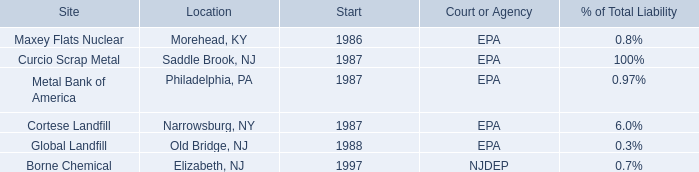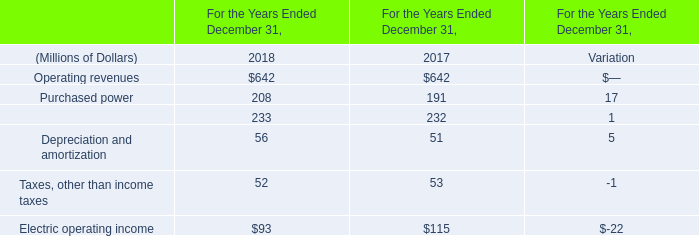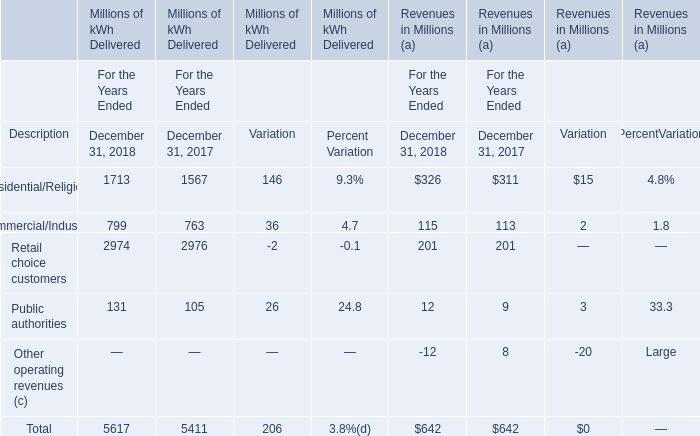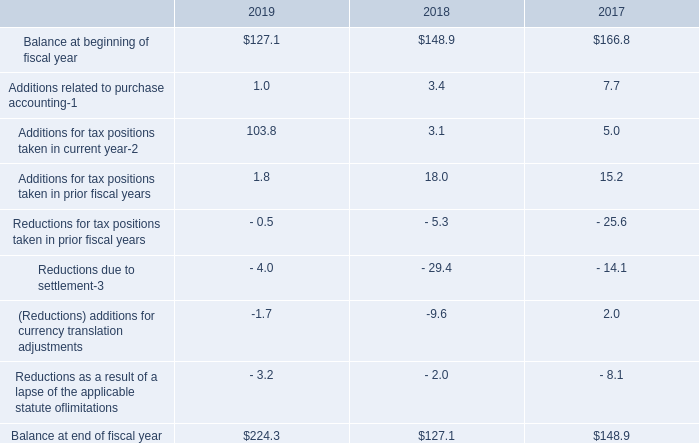What's the greatest value of Revenues in Millions (a) in December 31, 2018? 
Answer: Residential/Religious (b). 